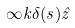<formula> <loc_0><loc_0><loc_500><loc_500>\infty k \delta ( s ) \hat { z }</formula> 